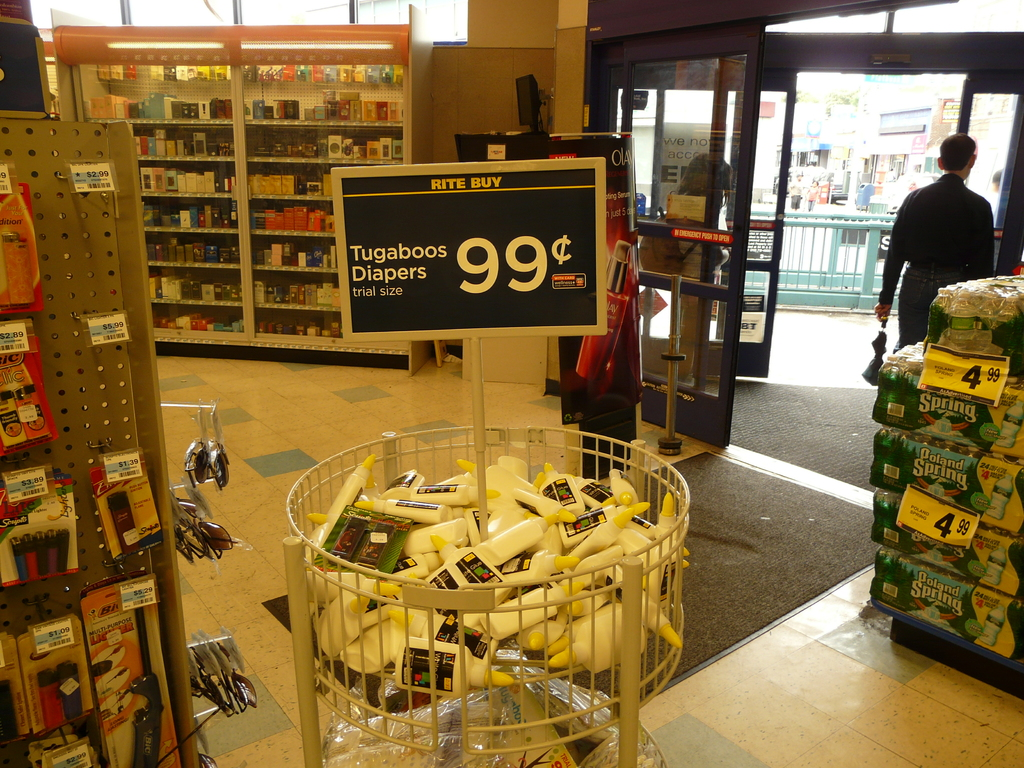What might be the marketing strategy behind the placement of items at the entrance? The strategic placement of promotional items like the Tugaboos Diapers at the store entrance is intended to capture customers' attention right away. It’s a common marketing tactic to place sale or trial-sized items in this area to encourage impulse buys or introduce customers to new products with the hope that they’ll return to purchase the full-sized versions. 